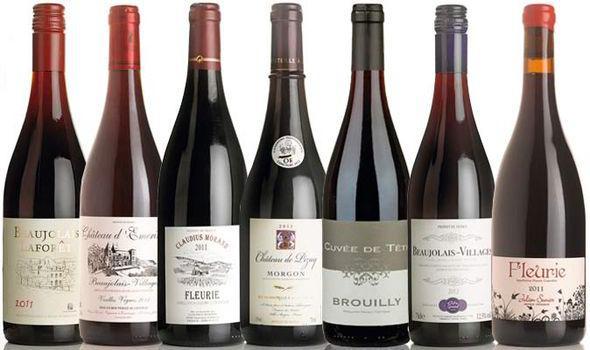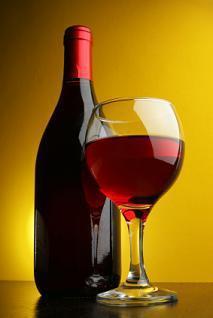The first image is the image on the left, the second image is the image on the right. Analyze the images presented: Is the assertion "there are at least seven wine bottles in the image on the left" valid? Answer yes or no. Yes. The first image is the image on the left, the second image is the image on the right. Assess this claim about the two images: "An image shows a horizontal row of at least 7 bottles, with no space between bottles.". Correct or not? Answer yes or no. Yes. 